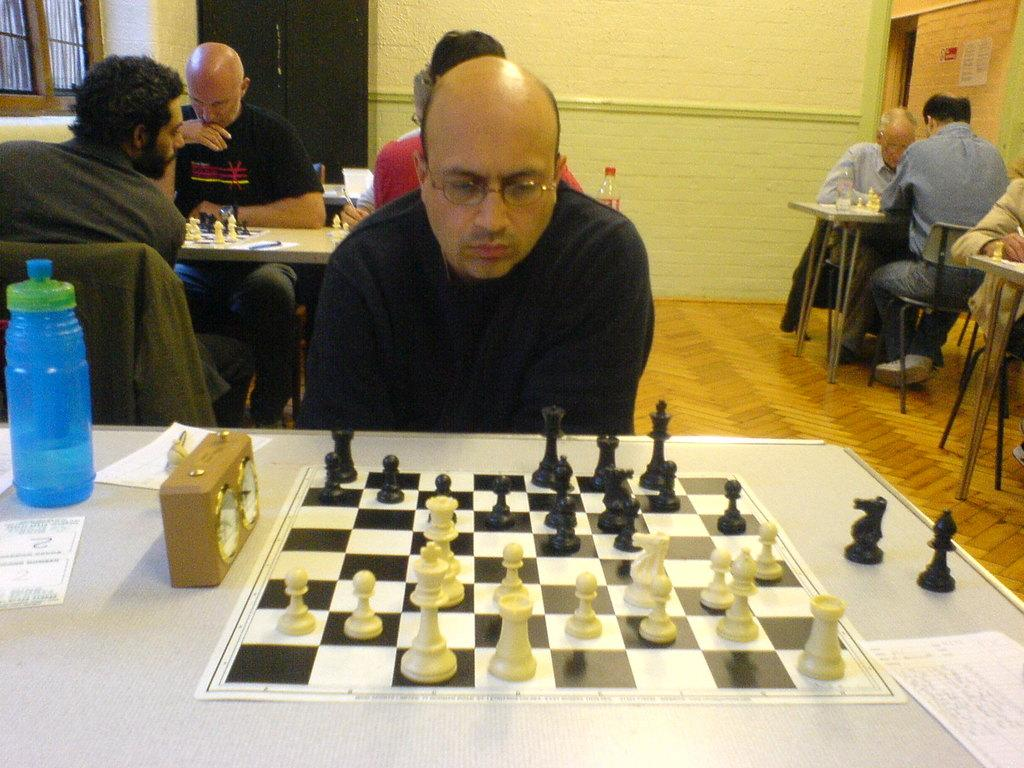What are the persons in the image doing? The persons in the image are playing chess. Where are the persons sitting while playing chess? The persons are sitting in chairs. What are the tables in the image used for? The tables contain chess boards and bottles. How many chess boards can be seen in the image? There are at least two chess boards visible, as there are two tables in the image. Can you tell me where the store is located in the image? There is no store present in the image; it features persons playing chess at tables. What type of chain can be seen connecting the chess pieces in the image? There is no chain connecting the chess pieces in the image; the pieces are separate and not connected. 